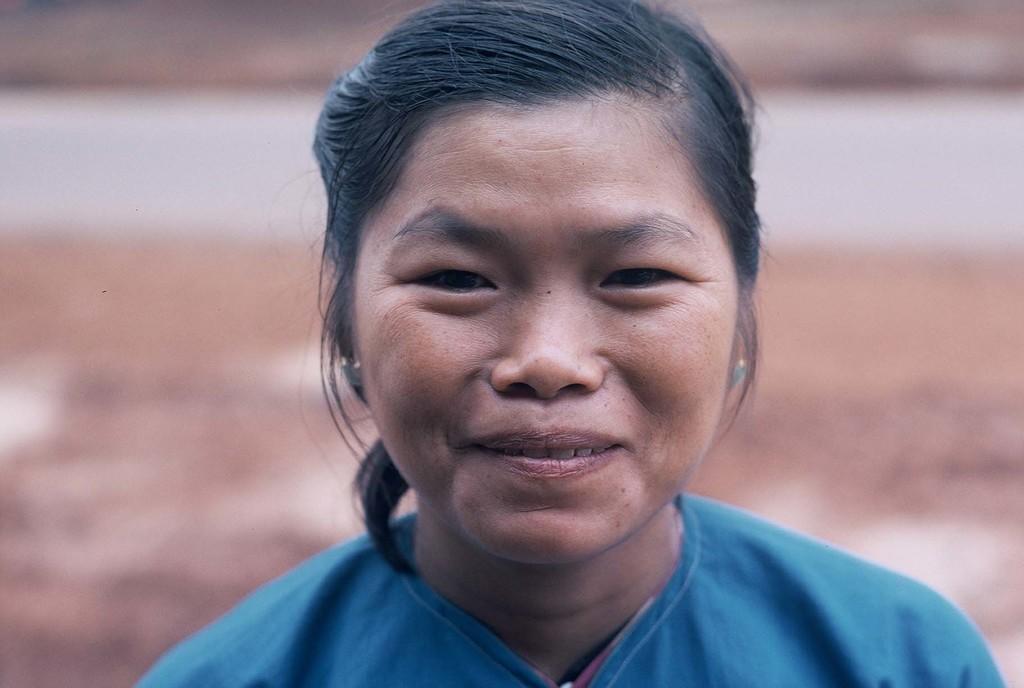Could you give a brief overview of what you see in this image? In the center of the image there is a lady wearing a blue color dress. she is smiling. 